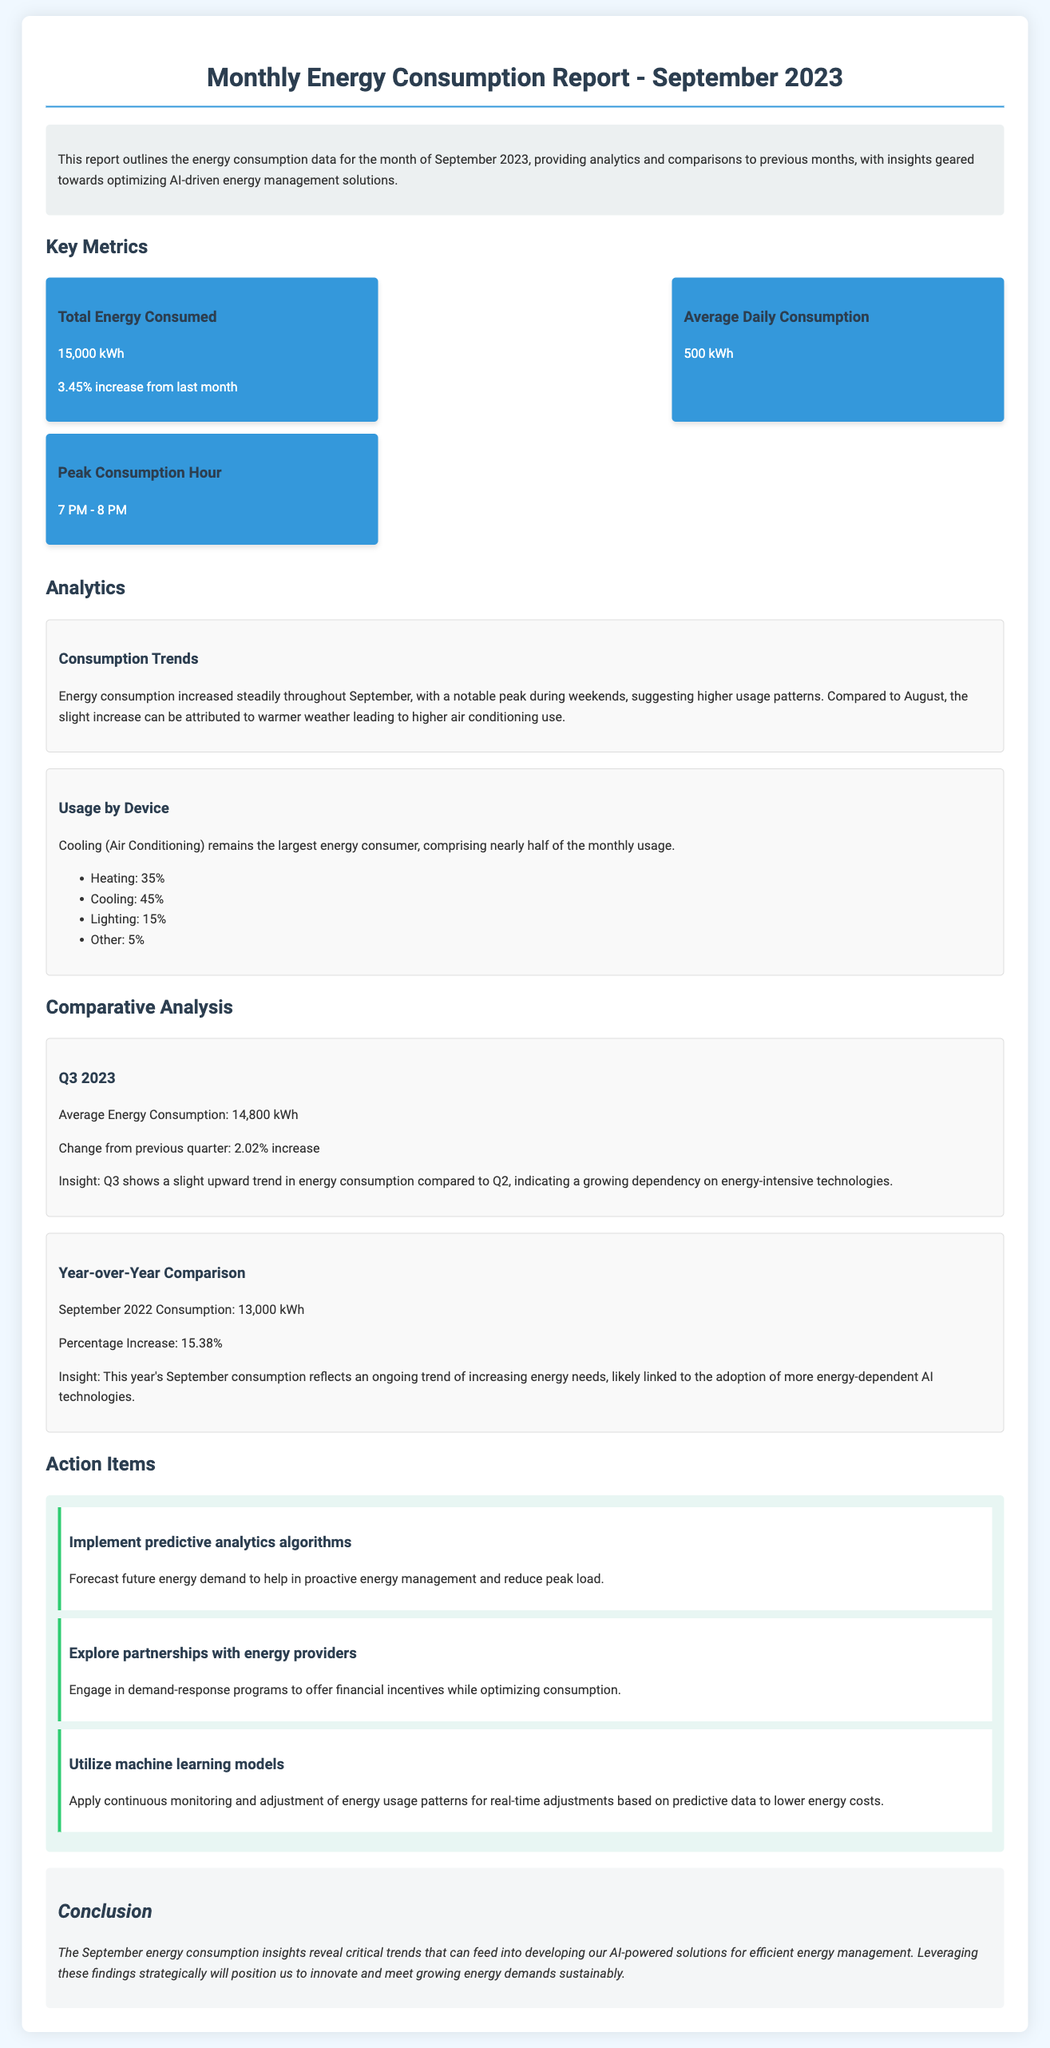What is the total energy consumed in September 2023? The total energy consumed is presented in the document under 'Total Energy Consumed.'
Answer: 15,000 kWh What is the percentage increase in total energy consumption from last month? The percentage increase is mentioned alongside the total energy consumed for September 2023.
Answer: 3.45% What was the average daily consumption for September 2023? The average daily consumption is listed in the 'Average Daily Consumption' section of the report.
Answer: 500 kWh What was the peak consumption hour in September 2023? The peak consumption hour is provided under 'Peak Consumption Hour' in the metrics section.
Answer: 7 PM - 8 PM What was the average energy consumption for Q3 2023? This information is found in the 'Comparative Analysis' section related to Q3 2023.
Answer: 14,800 kWh What percentage increase in energy consumption does this year's September reflect year-over-year? The percentage increase is outlined in the 'Year-over-Year Comparison' section of the report.
Answer: 15.38% What is the largest segment of energy consumption by device in September 2023? This information is mentioned in the 'Usage by Device' section, specifically about cooling.
Answer: Cooling What action item involves implementing predictive analytics? The specific action item can be found under the 'Action Items' section regarding predictive analytics.
Answer: Implement predictive analytics algorithms What is the main conclusion regarding the September energy consumption insights? The conclusion summarizes the overall findings of the report, particularly focusing on energy management solutions.
Answer: Energy management 